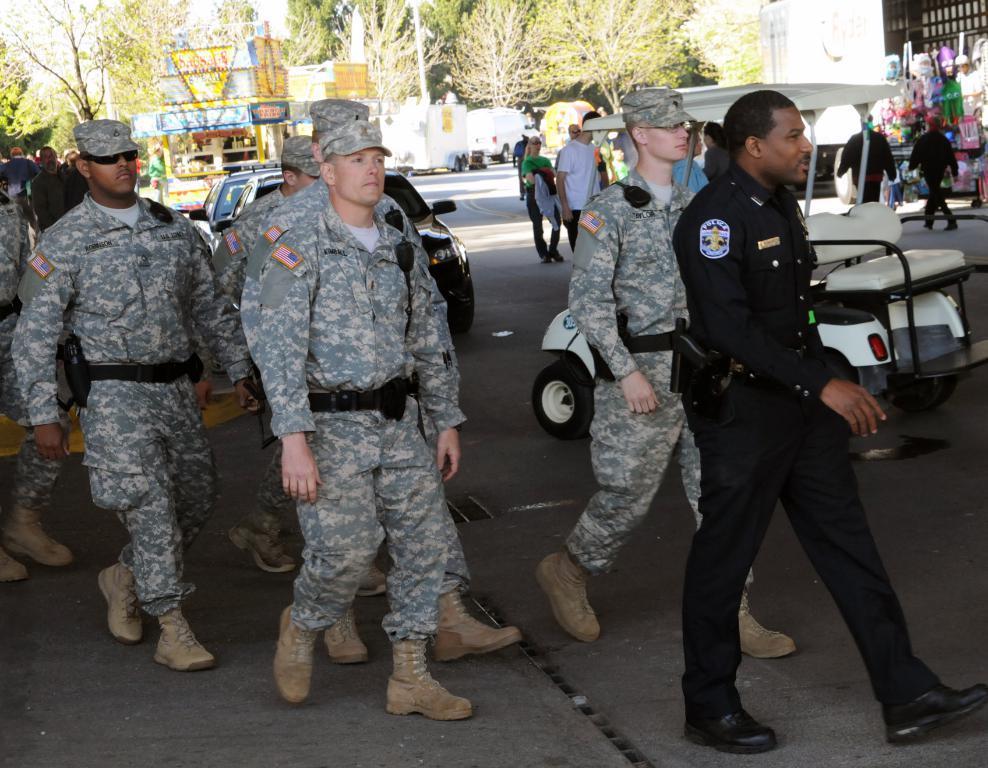Can you describe this image briefly? In this image there are people and we can see some of them are wearing uniforms. There are vehicles on the road. In the background there are buildings, trees, stalls and sky. 